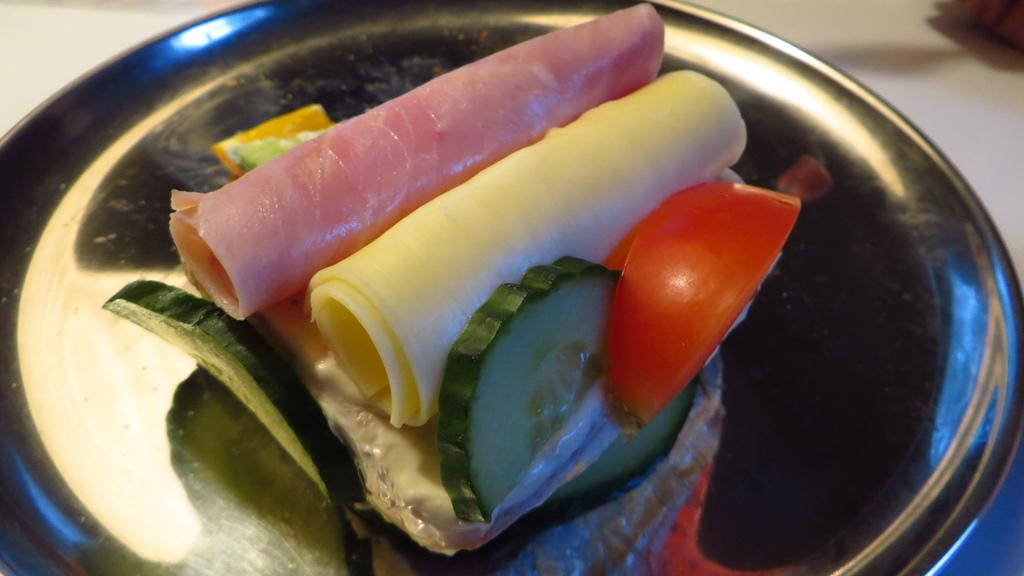What type of food can be seen in the image? There are vegetables and jelly rolls on a plate in the image. Where is the plate with the food located? The plate is on a table in the image. How does the earthquake affect the vegetables in the image? There is no earthquake present in the image, so the vegetables are not affected by one. 